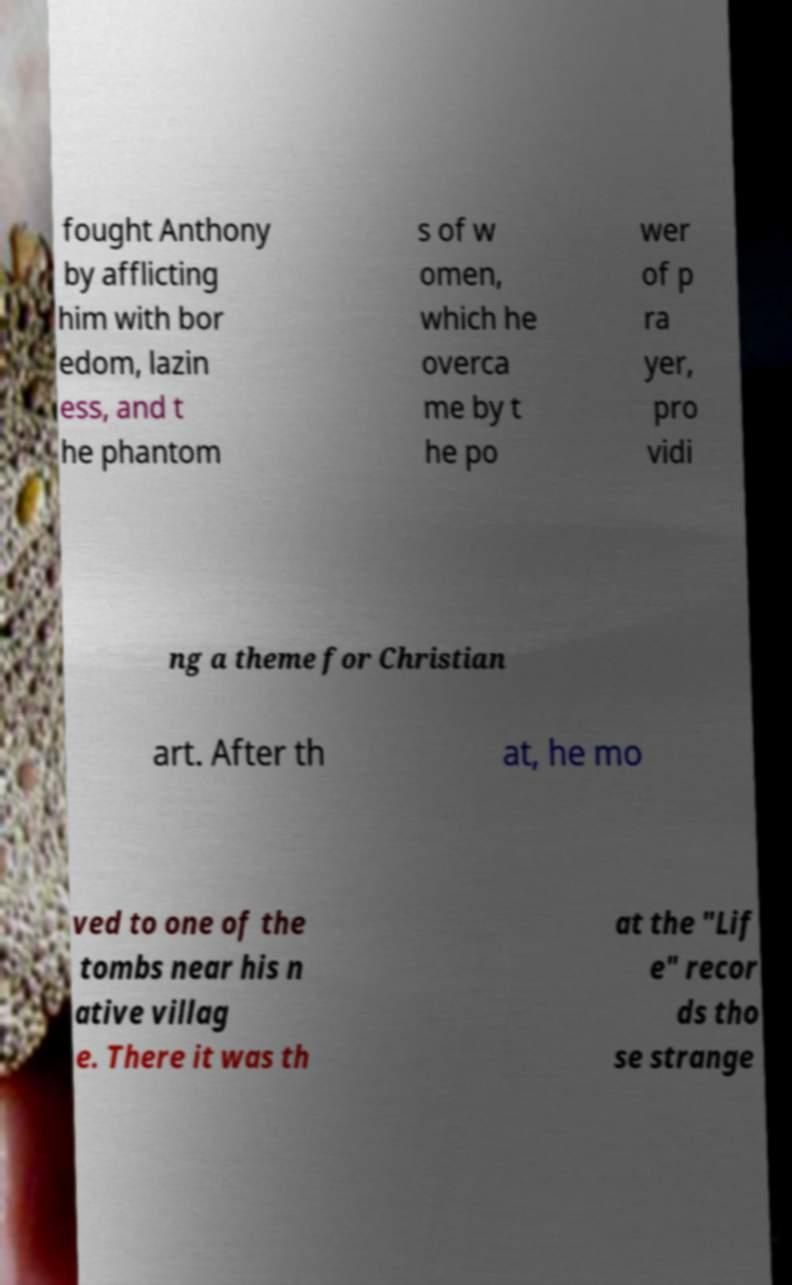Could you assist in decoding the text presented in this image and type it out clearly? fought Anthony by afflicting him with bor edom, lazin ess, and t he phantom s of w omen, which he overca me by t he po wer of p ra yer, pro vidi ng a theme for Christian art. After th at, he mo ved to one of the tombs near his n ative villag e. There it was th at the "Lif e" recor ds tho se strange 